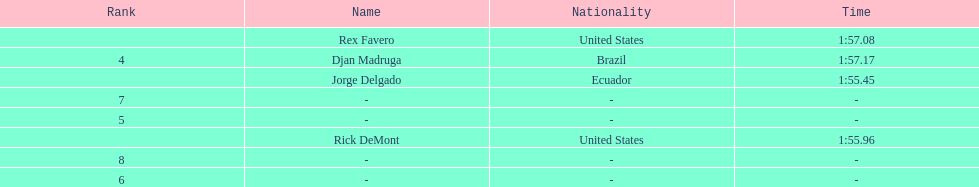0 1:57.17. 